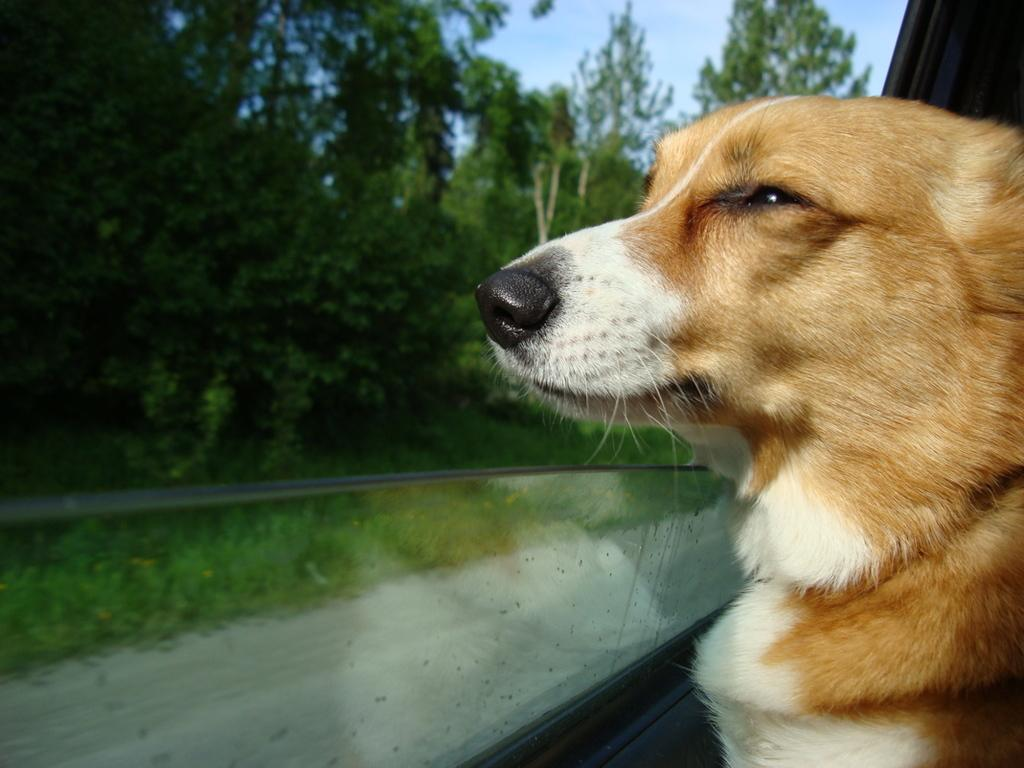What animal can be seen in the image? There is a dog in the image. What is the dog doing in the image? The dog is peeking through a motor vehicle's window. What can be seen in the background of the image? There is ground, trees, and the sky visible in the background of the image. How many brothers does the dog have in the image? There is no indication of any brothers in the image, as it features a dog peeking through a motor vehicle's window. 